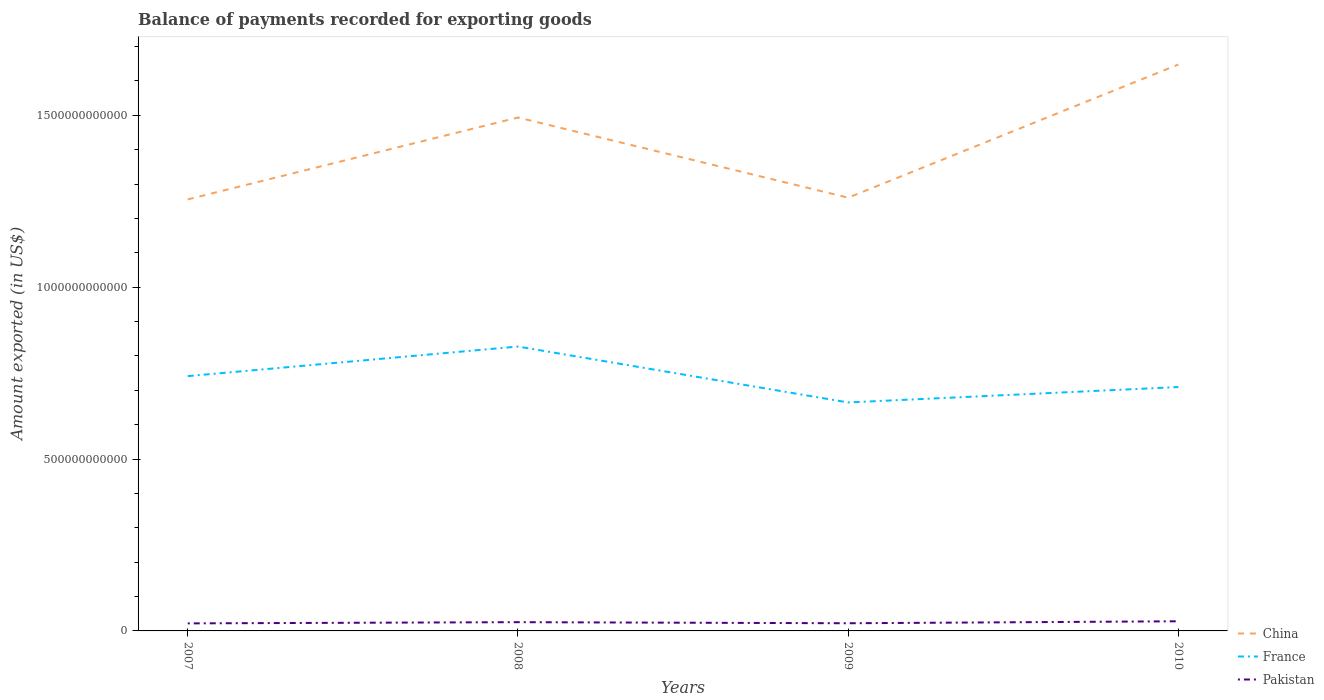How many different coloured lines are there?
Ensure brevity in your answer.  3. Is the number of lines equal to the number of legend labels?
Offer a terse response. Yes. Across all years, what is the maximum amount exported in France?
Provide a short and direct response. 6.65e+11. In which year was the amount exported in France maximum?
Provide a succinct answer. 2009. What is the total amount exported in France in the graph?
Offer a terse response. 7.66e+1. What is the difference between the highest and the second highest amount exported in Pakistan?
Offer a terse response. 6.11e+09. What is the difference between the highest and the lowest amount exported in China?
Keep it short and to the point. 2. Is the amount exported in France strictly greater than the amount exported in China over the years?
Your response must be concise. Yes. How many lines are there?
Provide a succinct answer. 3. What is the difference between two consecutive major ticks on the Y-axis?
Keep it short and to the point. 5.00e+11. Does the graph contain grids?
Ensure brevity in your answer.  No. How many legend labels are there?
Provide a short and direct response. 3. What is the title of the graph?
Offer a terse response. Balance of payments recorded for exporting goods. Does "North America" appear as one of the legend labels in the graph?
Ensure brevity in your answer.  No. What is the label or title of the Y-axis?
Your response must be concise. Amount exported (in US$). What is the Amount exported (in US$) in China in 2007?
Make the answer very short. 1.26e+12. What is the Amount exported (in US$) of France in 2007?
Give a very brief answer. 7.41e+11. What is the Amount exported (in US$) in Pakistan in 2007?
Your answer should be very brief. 2.19e+1. What is the Amount exported (in US$) of China in 2008?
Your answer should be very brief. 1.49e+12. What is the Amount exported (in US$) of France in 2008?
Offer a very short reply. 8.27e+11. What is the Amount exported (in US$) in Pakistan in 2008?
Offer a terse response. 2.55e+1. What is the Amount exported (in US$) of China in 2009?
Provide a short and direct response. 1.26e+12. What is the Amount exported (in US$) in France in 2009?
Give a very brief answer. 6.65e+11. What is the Amount exported (in US$) of Pakistan in 2009?
Your answer should be compact. 2.23e+1. What is the Amount exported (in US$) of China in 2010?
Make the answer very short. 1.65e+12. What is the Amount exported (in US$) in France in 2010?
Your response must be concise. 7.10e+11. What is the Amount exported (in US$) in Pakistan in 2010?
Your answer should be compact. 2.81e+1. Across all years, what is the maximum Amount exported (in US$) in China?
Ensure brevity in your answer.  1.65e+12. Across all years, what is the maximum Amount exported (in US$) of France?
Your answer should be compact. 8.27e+11. Across all years, what is the maximum Amount exported (in US$) of Pakistan?
Ensure brevity in your answer.  2.81e+1. Across all years, what is the minimum Amount exported (in US$) in China?
Make the answer very short. 1.26e+12. Across all years, what is the minimum Amount exported (in US$) in France?
Keep it short and to the point. 6.65e+11. Across all years, what is the minimum Amount exported (in US$) in Pakistan?
Provide a short and direct response. 2.19e+1. What is the total Amount exported (in US$) in China in the graph?
Provide a succinct answer. 5.66e+12. What is the total Amount exported (in US$) of France in the graph?
Your answer should be compact. 2.94e+12. What is the total Amount exported (in US$) of Pakistan in the graph?
Your response must be concise. 9.78e+1. What is the difference between the Amount exported (in US$) in China in 2007 and that in 2008?
Ensure brevity in your answer.  -2.38e+11. What is the difference between the Amount exported (in US$) of France in 2007 and that in 2008?
Give a very brief answer. -8.61e+1. What is the difference between the Amount exported (in US$) of Pakistan in 2007 and that in 2008?
Give a very brief answer. -3.53e+09. What is the difference between the Amount exported (in US$) in China in 2007 and that in 2009?
Ensure brevity in your answer.  -4.97e+09. What is the difference between the Amount exported (in US$) of France in 2007 and that in 2009?
Your answer should be very brief. 7.66e+1. What is the difference between the Amount exported (in US$) in Pakistan in 2007 and that in 2009?
Your answer should be compact. -3.69e+08. What is the difference between the Amount exported (in US$) of China in 2007 and that in 2010?
Your response must be concise. -3.92e+11. What is the difference between the Amount exported (in US$) of France in 2007 and that in 2010?
Provide a short and direct response. 3.17e+1. What is the difference between the Amount exported (in US$) of Pakistan in 2007 and that in 2010?
Keep it short and to the point. -6.11e+09. What is the difference between the Amount exported (in US$) of China in 2008 and that in 2009?
Provide a short and direct response. 2.33e+11. What is the difference between the Amount exported (in US$) of France in 2008 and that in 2009?
Ensure brevity in your answer.  1.63e+11. What is the difference between the Amount exported (in US$) in Pakistan in 2008 and that in 2009?
Provide a succinct answer. 3.16e+09. What is the difference between the Amount exported (in US$) in China in 2008 and that in 2010?
Ensure brevity in your answer.  -1.54e+11. What is the difference between the Amount exported (in US$) of France in 2008 and that in 2010?
Give a very brief answer. 1.18e+11. What is the difference between the Amount exported (in US$) of Pakistan in 2008 and that in 2010?
Ensure brevity in your answer.  -2.59e+09. What is the difference between the Amount exported (in US$) of China in 2009 and that in 2010?
Provide a short and direct response. -3.87e+11. What is the difference between the Amount exported (in US$) in France in 2009 and that in 2010?
Your answer should be very brief. -4.49e+1. What is the difference between the Amount exported (in US$) in Pakistan in 2009 and that in 2010?
Keep it short and to the point. -5.74e+09. What is the difference between the Amount exported (in US$) in China in 2007 and the Amount exported (in US$) in France in 2008?
Ensure brevity in your answer.  4.28e+11. What is the difference between the Amount exported (in US$) of China in 2007 and the Amount exported (in US$) of Pakistan in 2008?
Give a very brief answer. 1.23e+12. What is the difference between the Amount exported (in US$) in France in 2007 and the Amount exported (in US$) in Pakistan in 2008?
Your answer should be compact. 7.16e+11. What is the difference between the Amount exported (in US$) in China in 2007 and the Amount exported (in US$) in France in 2009?
Keep it short and to the point. 5.91e+11. What is the difference between the Amount exported (in US$) of China in 2007 and the Amount exported (in US$) of Pakistan in 2009?
Ensure brevity in your answer.  1.23e+12. What is the difference between the Amount exported (in US$) of France in 2007 and the Amount exported (in US$) of Pakistan in 2009?
Offer a very short reply. 7.19e+11. What is the difference between the Amount exported (in US$) of China in 2007 and the Amount exported (in US$) of France in 2010?
Make the answer very short. 5.46e+11. What is the difference between the Amount exported (in US$) in China in 2007 and the Amount exported (in US$) in Pakistan in 2010?
Keep it short and to the point. 1.23e+12. What is the difference between the Amount exported (in US$) of France in 2007 and the Amount exported (in US$) of Pakistan in 2010?
Offer a very short reply. 7.13e+11. What is the difference between the Amount exported (in US$) in China in 2008 and the Amount exported (in US$) in France in 2009?
Offer a very short reply. 8.29e+11. What is the difference between the Amount exported (in US$) in China in 2008 and the Amount exported (in US$) in Pakistan in 2009?
Ensure brevity in your answer.  1.47e+12. What is the difference between the Amount exported (in US$) of France in 2008 and the Amount exported (in US$) of Pakistan in 2009?
Make the answer very short. 8.05e+11. What is the difference between the Amount exported (in US$) in China in 2008 and the Amount exported (in US$) in France in 2010?
Your answer should be compact. 7.84e+11. What is the difference between the Amount exported (in US$) in China in 2008 and the Amount exported (in US$) in Pakistan in 2010?
Offer a terse response. 1.47e+12. What is the difference between the Amount exported (in US$) in France in 2008 and the Amount exported (in US$) in Pakistan in 2010?
Your answer should be compact. 7.99e+11. What is the difference between the Amount exported (in US$) in China in 2009 and the Amount exported (in US$) in France in 2010?
Give a very brief answer. 5.51e+11. What is the difference between the Amount exported (in US$) in China in 2009 and the Amount exported (in US$) in Pakistan in 2010?
Ensure brevity in your answer.  1.23e+12. What is the difference between the Amount exported (in US$) in France in 2009 and the Amount exported (in US$) in Pakistan in 2010?
Offer a very short reply. 6.37e+11. What is the average Amount exported (in US$) in China per year?
Offer a terse response. 1.41e+12. What is the average Amount exported (in US$) of France per year?
Provide a short and direct response. 7.36e+11. What is the average Amount exported (in US$) of Pakistan per year?
Your answer should be compact. 2.44e+1. In the year 2007, what is the difference between the Amount exported (in US$) of China and Amount exported (in US$) of France?
Give a very brief answer. 5.14e+11. In the year 2007, what is the difference between the Amount exported (in US$) in China and Amount exported (in US$) in Pakistan?
Offer a very short reply. 1.23e+12. In the year 2007, what is the difference between the Amount exported (in US$) of France and Amount exported (in US$) of Pakistan?
Offer a very short reply. 7.19e+11. In the year 2008, what is the difference between the Amount exported (in US$) in China and Amount exported (in US$) in France?
Give a very brief answer. 6.66e+11. In the year 2008, what is the difference between the Amount exported (in US$) in China and Amount exported (in US$) in Pakistan?
Keep it short and to the point. 1.47e+12. In the year 2008, what is the difference between the Amount exported (in US$) of France and Amount exported (in US$) of Pakistan?
Keep it short and to the point. 8.02e+11. In the year 2009, what is the difference between the Amount exported (in US$) in China and Amount exported (in US$) in France?
Give a very brief answer. 5.96e+11. In the year 2009, what is the difference between the Amount exported (in US$) in China and Amount exported (in US$) in Pakistan?
Your answer should be compact. 1.24e+12. In the year 2009, what is the difference between the Amount exported (in US$) of France and Amount exported (in US$) of Pakistan?
Your answer should be very brief. 6.42e+11. In the year 2010, what is the difference between the Amount exported (in US$) of China and Amount exported (in US$) of France?
Ensure brevity in your answer.  9.38e+11. In the year 2010, what is the difference between the Amount exported (in US$) in China and Amount exported (in US$) in Pakistan?
Your response must be concise. 1.62e+12. In the year 2010, what is the difference between the Amount exported (in US$) of France and Amount exported (in US$) of Pakistan?
Your answer should be very brief. 6.81e+11. What is the ratio of the Amount exported (in US$) of China in 2007 to that in 2008?
Your answer should be compact. 0.84. What is the ratio of the Amount exported (in US$) of France in 2007 to that in 2008?
Ensure brevity in your answer.  0.9. What is the ratio of the Amount exported (in US$) in Pakistan in 2007 to that in 2008?
Provide a short and direct response. 0.86. What is the ratio of the Amount exported (in US$) of France in 2007 to that in 2009?
Keep it short and to the point. 1.12. What is the ratio of the Amount exported (in US$) in Pakistan in 2007 to that in 2009?
Ensure brevity in your answer.  0.98. What is the ratio of the Amount exported (in US$) of China in 2007 to that in 2010?
Your answer should be compact. 0.76. What is the ratio of the Amount exported (in US$) of France in 2007 to that in 2010?
Offer a very short reply. 1.04. What is the ratio of the Amount exported (in US$) of Pakistan in 2007 to that in 2010?
Provide a short and direct response. 0.78. What is the ratio of the Amount exported (in US$) of China in 2008 to that in 2009?
Provide a succinct answer. 1.19. What is the ratio of the Amount exported (in US$) in France in 2008 to that in 2009?
Offer a very short reply. 1.24. What is the ratio of the Amount exported (in US$) in Pakistan in 2008 to that in 2009?
Ensure brevity in your answer.  1.14. What is the ratio of the Amount exported (in US$) of China in 2008 to that in 2010?
Provide a short and direct response. 0.91. What is the ratio of the Amount exported (in US$) of France in 2008 to that in 2010?
Your response must be concise. 1.17. What is the ratio of the Amount exported (in US$) in Pakistan in 2008 to that in 2010?
Provide a succinct answer. 0.91. What is the ratio of the Amount exported (in US$) in China in 2009 to that in 2010?
Your response must be concise. 0.76. What is the ratio of the Amount exported (in US$) of France in 2009 to that in 2010?
Provide a short and direct response. 0.94. What is the ratio of the Amount exported (in US$) in Pakistan in 2009 to that in 2010?
Your answer should be very brief. 0.8. What is the difference between the highest and the second highest Amount exported (in US$) in China?
Ensure brevity in your answer.  1.54e+11. What is the difference between the highest and the second highest Amount exported (in US$) of France?
Keep it short and to the point. 8.61e+1. What is the difference between the highest and the second highest Amount exported (in US$) of Pakistan?
Ensure brevity in your answer.  2.59e+09. What is the difference between the highest and the lowest Amount exported (in US$) in China?
Offer a terse response. 3.92e+11. What is the difference between the highest and the lowest Amount exported (in US$) of France?
Provide a short and direct response. 1.63e+11. What is the difference between the highest and the lowest Amount exported (in US$) in Pakistan?
Your answer should be compact. 6.11e+09. 